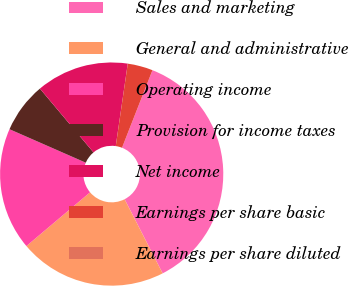Convert chart. <chart><loc_0><loc_0><loc_500><loc_500><pie_chart><fcel>Sales and marketing<fcel>General and administrative<fcel>Operating income<fcel>Provision for income taxes<fcel>Net income<fcel>Earnings per share basic<fcel>Earnings per share diluted<nl><fcel>36.5%<fcel>21.39%<fcel>17.74%<fcel>7.3%<fcel>13.42%<fcel>3.65%<fcel>0.0%<nl></chart> 